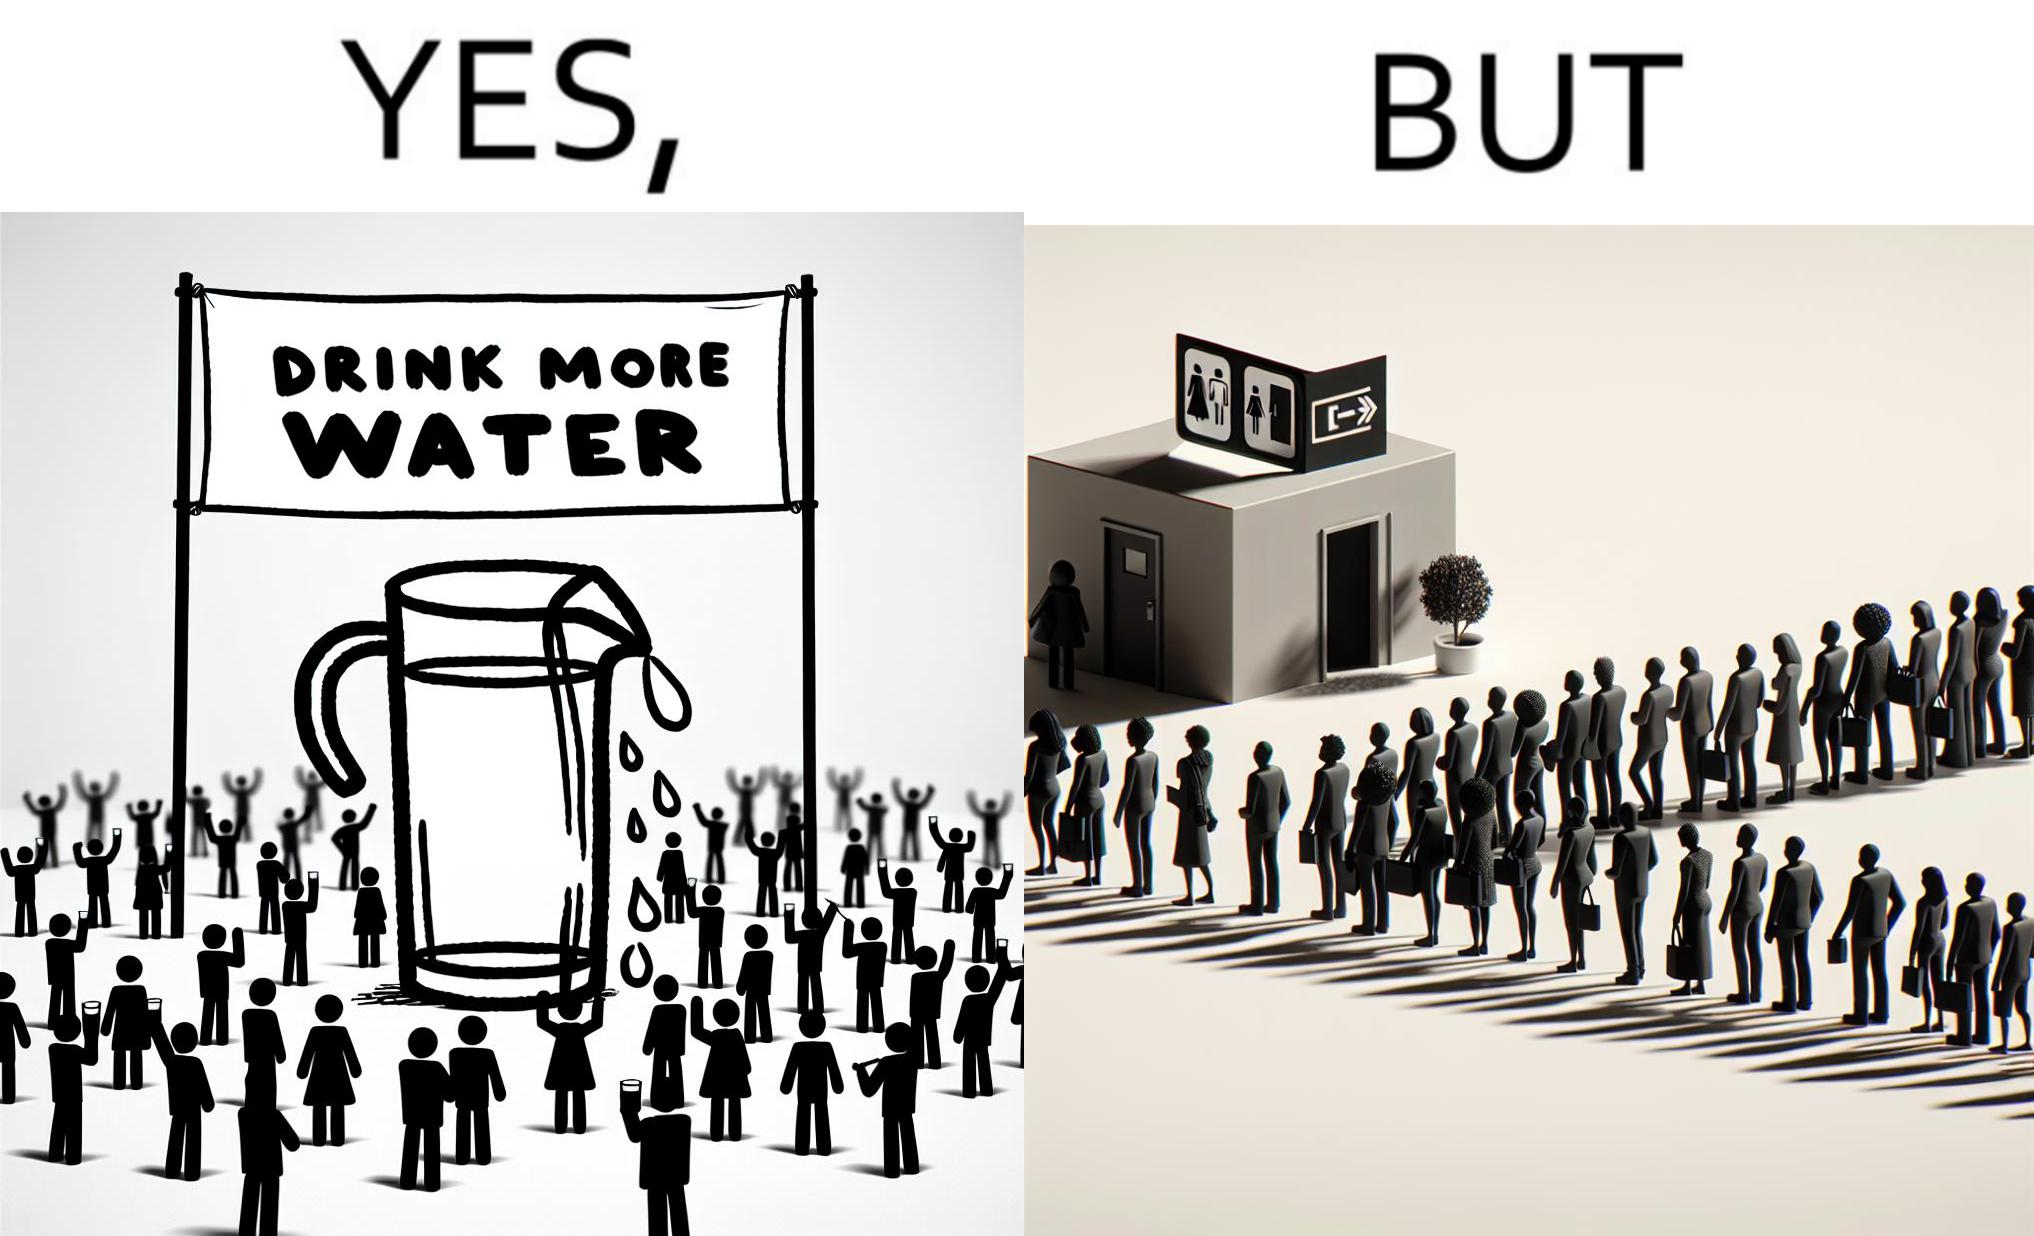Describe the contrast between the left and right parts of this image. In the left part of the image: A banner that says "Drink more water" with an image of a jug pouring water into a glass. In the right part of the image: a very long queue in front of the public toilet 